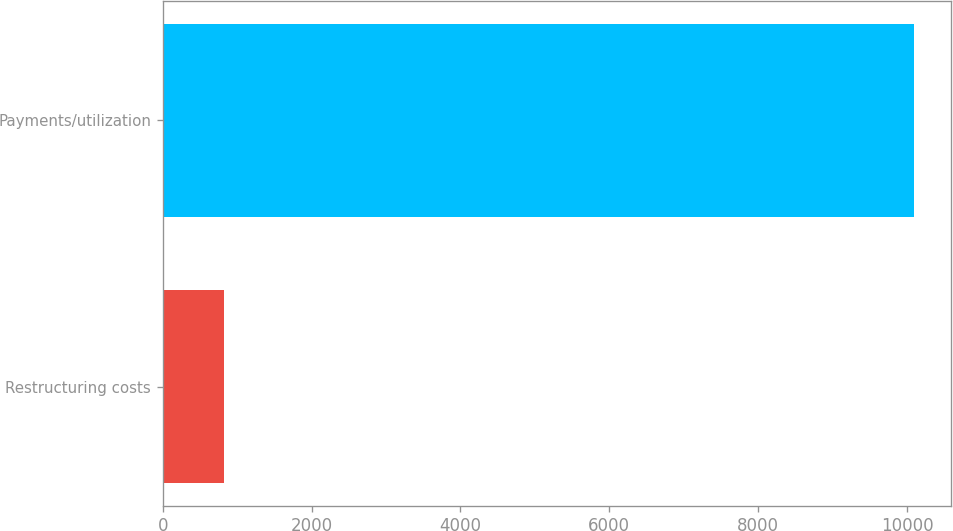<chart> <loc_0><loc_0><loc_500><loc_500><bar_chart><fcel>Restructuring costs<fcel>Payments/utilization<nl><fcel>828<fcel>10091<nl></chart> 